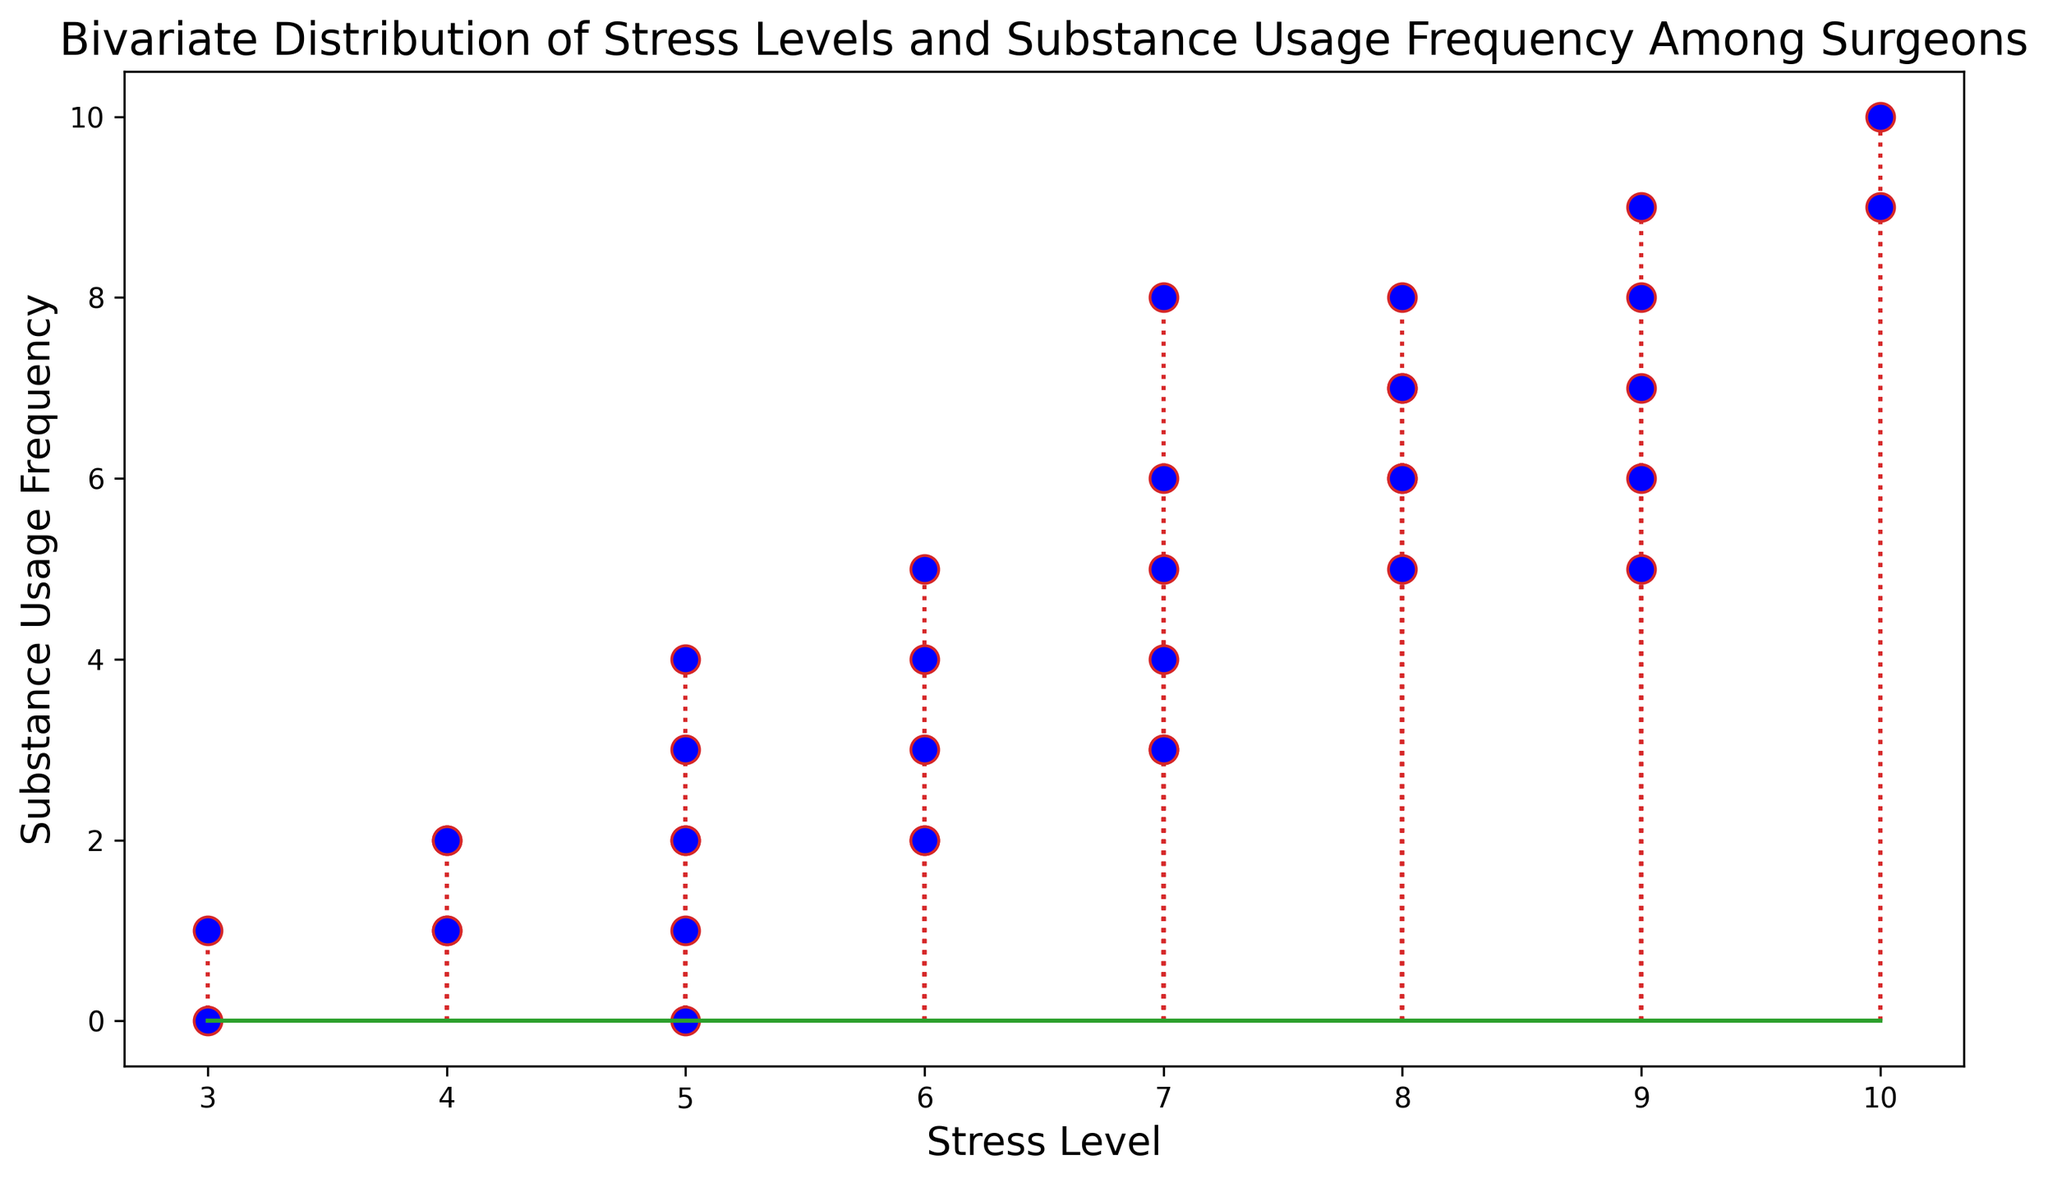What is the maximum stress level observed in the plot? Look for the highest value on the x-axis, where the stress levels are plotted. Identify the largest number.
Answer: 10 Which stress level corresponds to the highest substance usage frequency? Check the y-axis for the highest substance usage frequency. Identify the stress level at this point.
Answer: 10 Is there a stress level where substance usage frequency is 0? Look along the x-axis for the stress level and find if there's a y-value of 0.
Answer: 3 How does the substance usage frequency change as stress levels increase from 4 to 6? Observe the markers on the plot between stress levels 4 and 6 and note the trend in y-values.
Answer: Generally increases What is the average substance usage frequency for stress levels of 7? Identify all y-values where the stress level is 7. Sum these values and divide by the number of occurrences. (8+3+5+6+4) / 5 = 26 / 5.
Answer: 5.2 For stress levels 9 and 10, which has a higher average substance usage frequency? Calculate the average usage frequency for stress levels 9 (7+9+6+8) / 4 = 7.5 and 10 (10+9) / 2 = 9. Compare the two values.
Answer: 10 Which stress level has the most variability in substance usage frequency? Identify stress levels with multiple y-values and compare the range of those values.
Answer: 7 Does the plot indicate a general trend between stress levels and substance usage frequency? Observe the overall pattern of the markers and stems. Determine if there is an increasing or decreasing trend.
Answer: Increasing trend What is the frequency of substance usage when the stress level is 8? Identify all instances where the x-axis has a value of 8 and list the corresponding y-values.
Answer: 6, 7, 5, 8 Is there any stress level where the substance usage frequency remains constant? Check if any stress level has multiple points with the same y-value.
Answer: No, all vary 